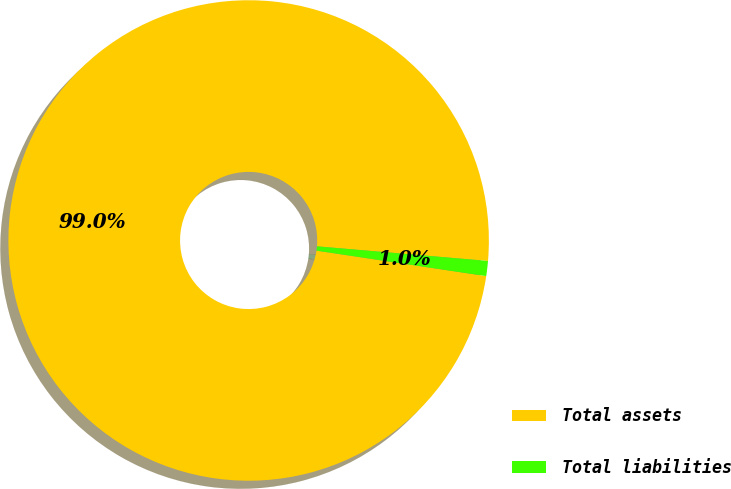Convert chart to OTSL. <chart><loc_0><loc_0><loc_500><loc_500><pie_chart><fcel>Total assets<fcel>Total liabilities<nl><fcel>98.99%<fcel>1.01%<nl></chart> 